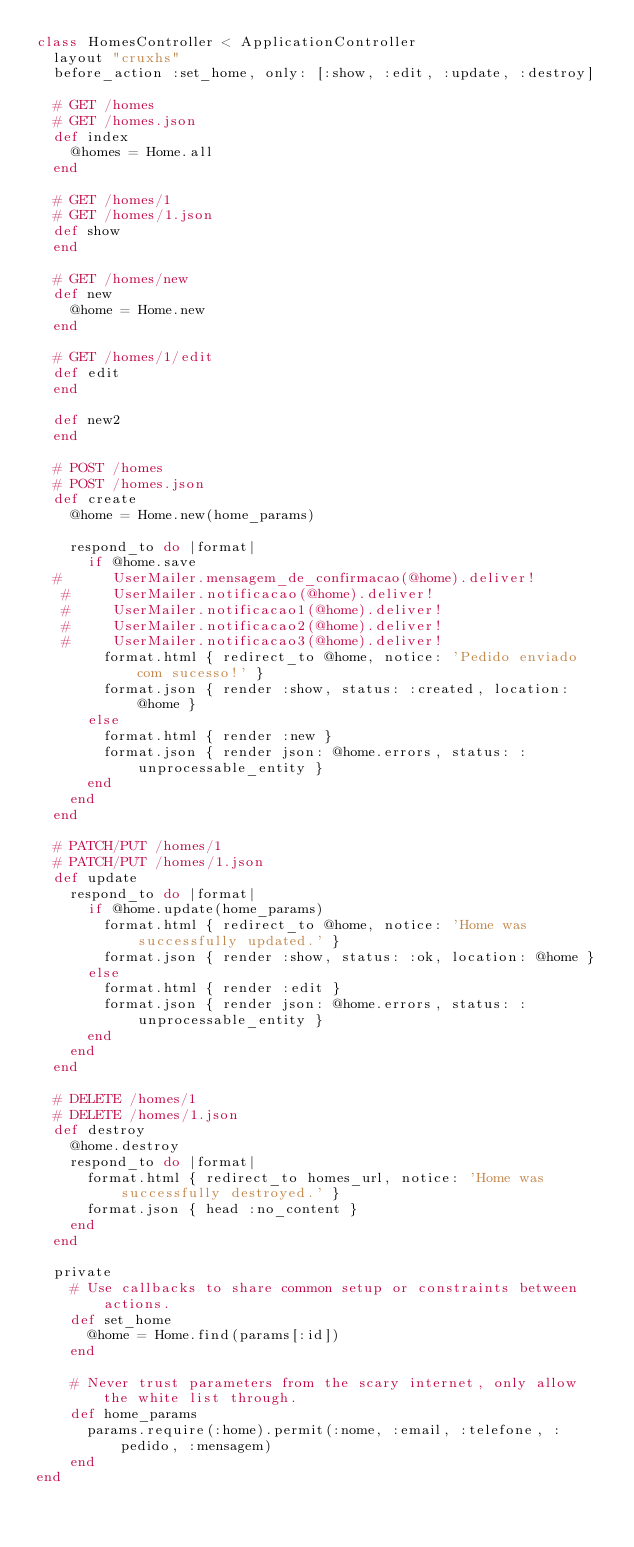Convert code to text. <code><loc_0><loc_0><loc_500><loc_500><_Ruby_>class HomesController < ApplicationController
  layout "cruxhs"
  before_action :set_home, only: [:show, :edit, :update, :destroy]

  # GET /homes
  # GET /homes.json
  def index
    @homes = Home.all
  end

  # GET /homes/1
  # GET /homes/1.json
  def show
  end

  # GET /homes/new
  def new
    @home = Home.new
  end

  # GET /homes/1/edit
  def edit
  end

  def new2
  end

  # POST /homes
  # POST /homes.json
  def create
    @home = Home.new(home_params)

    respond_to do |format|
      if @home.save
  #      UserMailer.mensagem_de_confirmacao(@home).deliver!
   #     UserMailer.notificacao(@home).deliver!
   #     UserMailer.notificacao1(@home).deliver!
   #     UserMailer.notificacao2(@home).deliver!
   #     UserMailer.notificacao3(@home).deliver!
        format.html { redirect_to @home, notice: 'Pedido enviado com sucesso!' }
        format.json { render :show, status: :created, location: @home }
      else
        format.html { render :new }
        format.json { render json: @home.errors, status: :unprocessable_entity }
      end
    end
  end

  # PATCH/PUT /homes/1
  # PATCH/PUT /homes/1.json
  def update
    respond_to do |format|
      if @home.update(home_params)
        format.html { redirect_to @home, notice: 'Home was successfully updated.' }
        format.json { render :show, status: :ok, location: @home }
      else
        format.html { render :edit }
        format.json { render json: @home.errors, status: :unprocessable_entity }
      end
    end
  end

  # DELETE /homes/1
  # DELETE /homes/1.json
  def destroy
    @home.destroy
    respond_to do |format|
      format.html { redirect_to homes_url, notice: 'Home was successfully destroyed.' }
      format.json { head :no_content }
    end
  end

  private
    # Use callbacks to share common setup or constraints between actions.
    def set_home
      @home = Home.find(params[:id])
    end

    # Never trust parameters from the scary internet, only allow the white list through.
    def home_params
      params.require(:home).permit(:nome, :email, :telefone, :pedido, :mensagem)
    end
end
</code> 